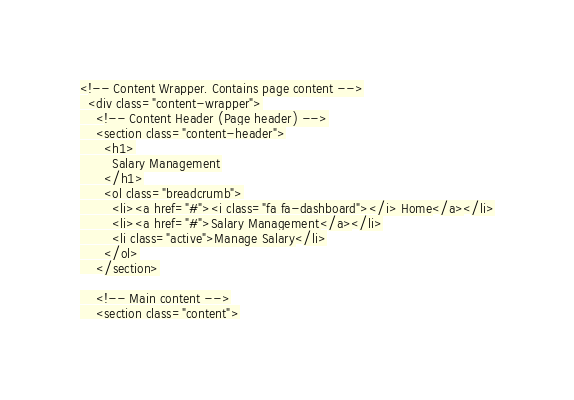Convert code to text. <code><loc_0><loc_0><loc_500><loc_500><_PHP_><!-- Content Wrapper. Contains page content -->
  <div class="content-wrapper">
    <!-- Content Header (Page header) -->
    <section class="content-header">
      <h1>
        Salary Management
      </h1>
      <ol class="breadcrumb">
        <li><a href="#"><i class="fa fa-dashboard"></i> Home</a></li>
        <li><a href="#">Salary Management</a></li>
        <li class="active">Manage Salary</li>
      </ol>
    </section>

    <!-- Main content -->
    <section class="content"></code> 